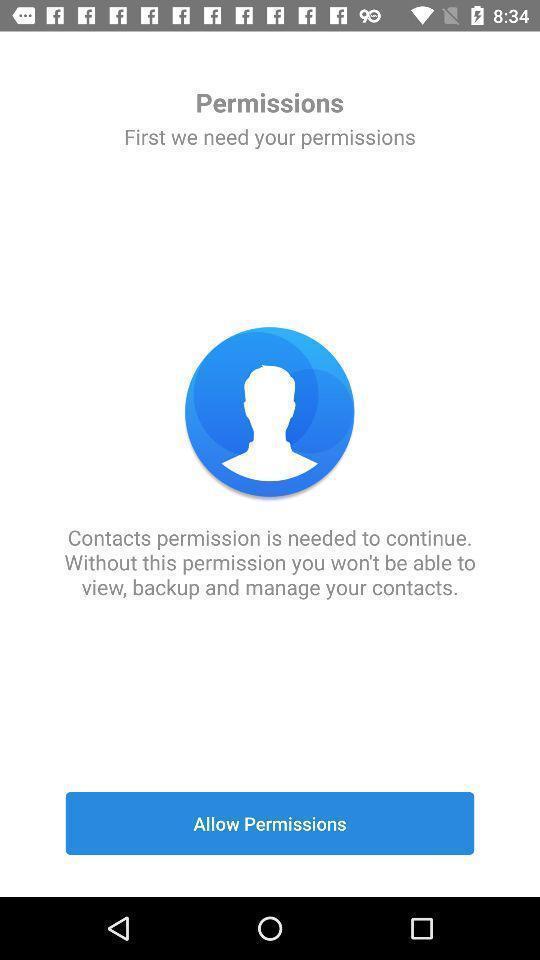Give me a summary of this screen capture. Screen showing allow permissions options. 